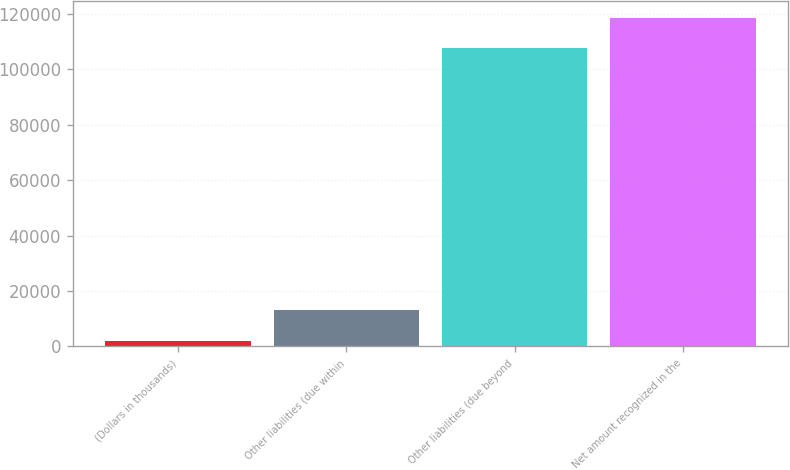Convert chart. <chart><loc_0><loc_0><loc_500><loc_500><bar_chart><fcel>(Dollars in thousands)<fcel>Other liabilities (due within<fcel>Other liabilities (due beyond<fcel>Net amount recognized in the<nl><fcel>2014<fcel>13110.2<fcel>107507<fcel>118603<nl></chart> 